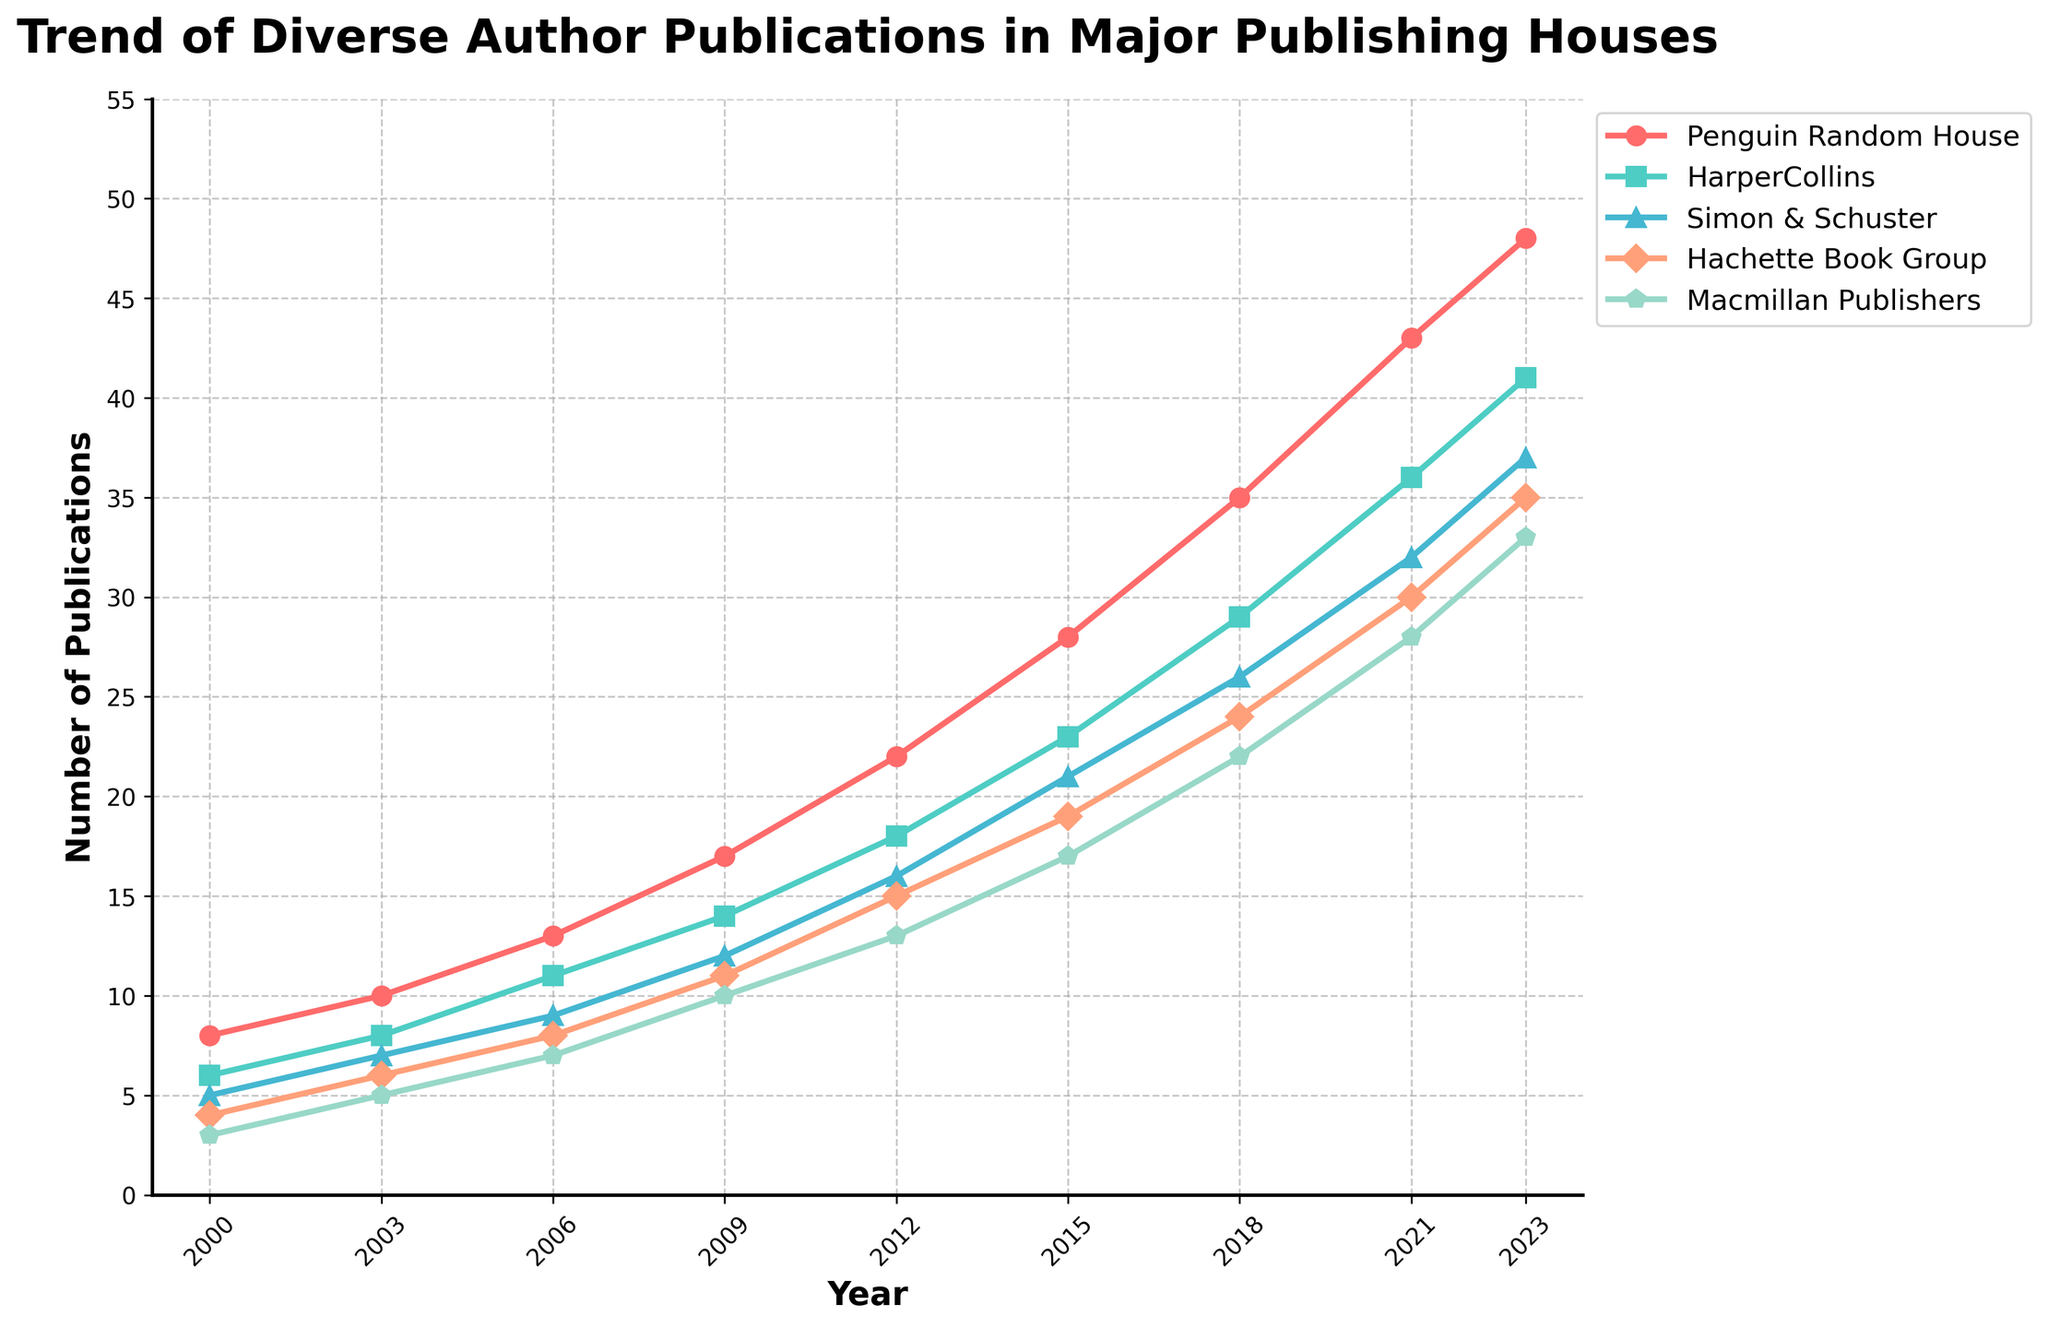What is the trend of diverse author publications in Penguin Random House from 2000 to 2023? From the graph, the number of diverse author publications in Penguin Random House has increased gradually from 8 in 2000 to 48 in 2023. This shows a consistent upward trend over the years.
Answer: Increasing Which publishing house had the highest number of diverse author publications in 2023? By looking at the chart, Penguin Random House had 48 publications, the highest among the five publishing houses listed.
Answer: Penguin Random House How does the growth rate in diverse author publications between 2000 and 2023 compare between HarperCollins and Simon & Schuster? HarperCollins increased from 6 to 41 publications, a growth of 35. Simon & Schuster increased from 5 to 37 publications, a growth of 32. HarperCollins saw a slightly higher increase compared to Simon & Schuster.
Answer: HarperCollins by 3 more publications What is the visual difference in the markers used for Penguin Random House and Macmillan Publishers? Penguin Random House uses circular markers, while Macmillan Publishers uses pentagon markers.
Answer: Circular vs. Pentagon What was the total number of diverse author publications in 2009 across all publishing houses shown? Adding up the publications for each house: 17 (Penguin Random House) + 14 (HarperCollins) + 12 (Simon & Schuster) + 11 (Hachette Book Group) + 10 (Macmillan Publishers) = 64.
Answer: 64 Which publishing house had the smallest increase in diverse author publications between 2000 and 2023? By observing the growth, Hachette Book Group had an increase from 4 to 35, which is 31. This is the smallest increase among the publishing houses listed.
Answer: Hachette Book Group What was the annual growth rate of diverse author publications for Penguin Random House from 2000 to 2021? The number of publications increased from 8 to 43 over 21 years. The annual growth rate is (43 - 8) / 21 ≈ 1.67 publications per year.
Answer: 1.67 publications per year By how much did the diverse author publications of Macmillan Publishers increase between 2015 and 2023? In 2015, it was 17, and in 2023, it was 33. The increase is 33 - 17 = 16.
Answer: 16 